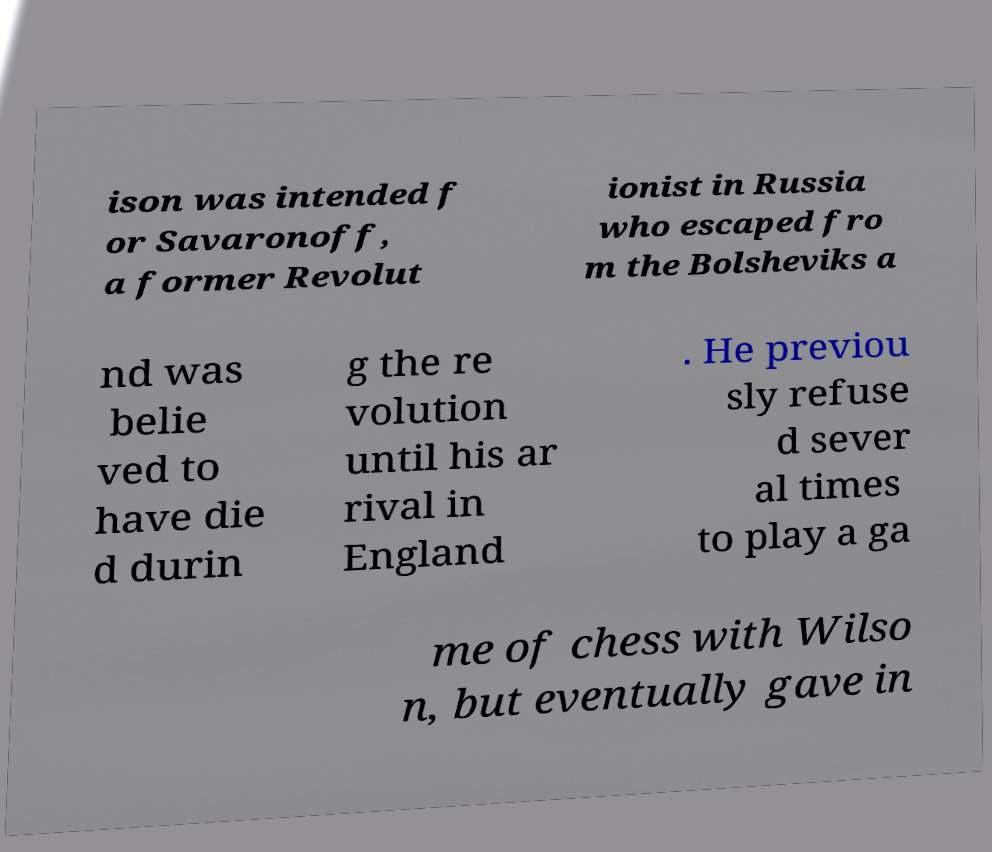Can you accurately transcribe the text from the provided image for me? ison was intended f or Savaronoff, a former Revolut ionist in Russia who escaped fro m the Bolsheviks a nd was belie ved to have die d durin g the re volution until his ar rival in England . He previou sly refuse d sever al times to play a ga me of chess with Wilso n, but eventually gave in 